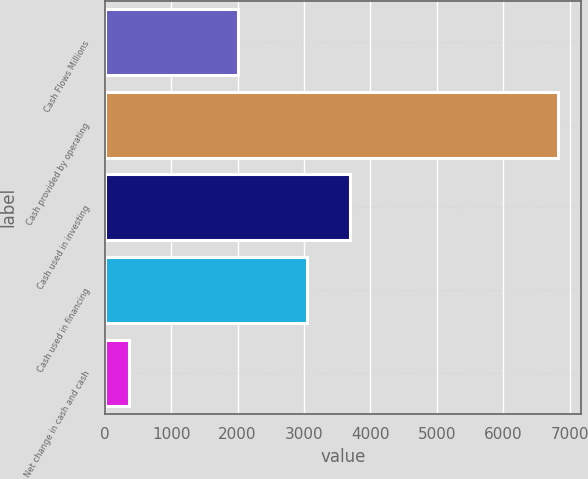<chart> <loc_0><loc_0><loc_500><loc_500><bar_chart><fcel>Cash Flows Millions<fcel>Cash provided by operating<fcel>Cash used in investing<fcel>Cash used in financing<fcel>Net change in cash and cash<nl><fcel>2013<fcel>6823<fcel>3694.4<fcel>3049<fcel>369<nl></chart> 